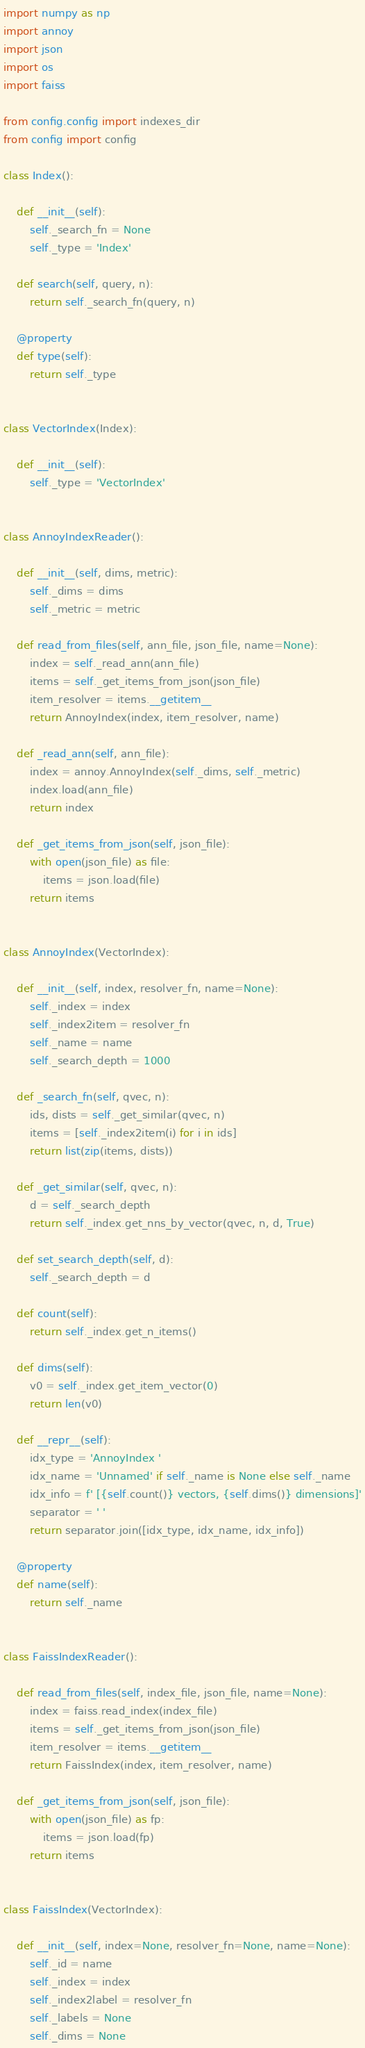Convert code to text. <code><loc_0><loc_0><loc_500><loc_500><_Python_>import numpy as np
import annoy
import json
import os
import faiss

from config.config import indexes_dir
from config import config

class Index():

    def __init__(self):
        self._search_fn = None
        self._type = 'Index'

    def search(self, query, n):
        return self._search_fn(query, n)

    @property
    def type(self):
        return self._type
    

class VectorIndex(Index):
    
    def __init__(self):
        self._type = 'VectorIndex'


class AnnoyIndexReader():

    def __init__(self, dims, metric):
        self._dims = dims
        self._metric = metric

    def read_from_files(self, ann_file, json_file, name=None):
        index = self._read_ann(ann_file)
        items = self._get_items_from_json(json_file)
        item_resolver = items.__getitem__
        return AnnoyIndex(index, item_resolver, name)

    def _read_ann(self, ann_file):
        index = annoy.AnnoyIndex(self._dims, self._metric)
        index.load(ann_file)
        return index

    def _get_items_from_json(self, json_file):
        with open(json_file) as file:
            items = json.load(file)
        return items


class AnnoyIndex(VectorIndex):

    def __init__(self, index, resolver_fn, name=None):
        self._index = index
        self._index2item = resolver_fn
        self._name = name
        self._search_depth = 1000

    def _search_fn(self, qvec, n):
        ids, dists = self._get_similar(qvec, n)
        items = [self._index2item(i) for i in ids]
        return list(zip(items, dists))

    def _get_similar(self, qvec, n):
        d = self._search_depth
        return self._index.get_nns_by_vector(qvec, n, d, True)

    def set_search_depth(self, d):
        self._search_depth = d

    def count(self):
        return self._index.get_n_items()

    def dims(self):
        v0 = self._index.get_item_vector(0)
        return len(v0)

    def __repr__(self):
        idx_type = 'AnnoyIndex '
        idx_name = 'Unnamed' if self._name is None else self._name
        idx_info = f' [{self.count()} vectors, {self.dims()} dimensions]'
        separator = ' '
        return separator.join([idx_type, idx_name, idx_info])

    @property
    def name(self):
        return self._name


class FaissIndexReader():

    def read_from_files(self, index_file, json_file, name=None):
        index = faiss.read_index(index_file)
        items = self._get_items_from_json(json_file)
        item_resolver = items.__getitem__
        return FaissIndex(index, item_resolver, name)

    def _get_items_from_json(self, json_file):
        with open(json_file) as fp:
            items = json.load(fp)
        return items


class FaissIndex(VectorIndex):

    def __init__(self, index=None, resolver_fn=None, name=None):
        self._id = name
        self._index = index
        self._index2label = resolver_fn
        self._labels = None
        self._dims = None
</code> 